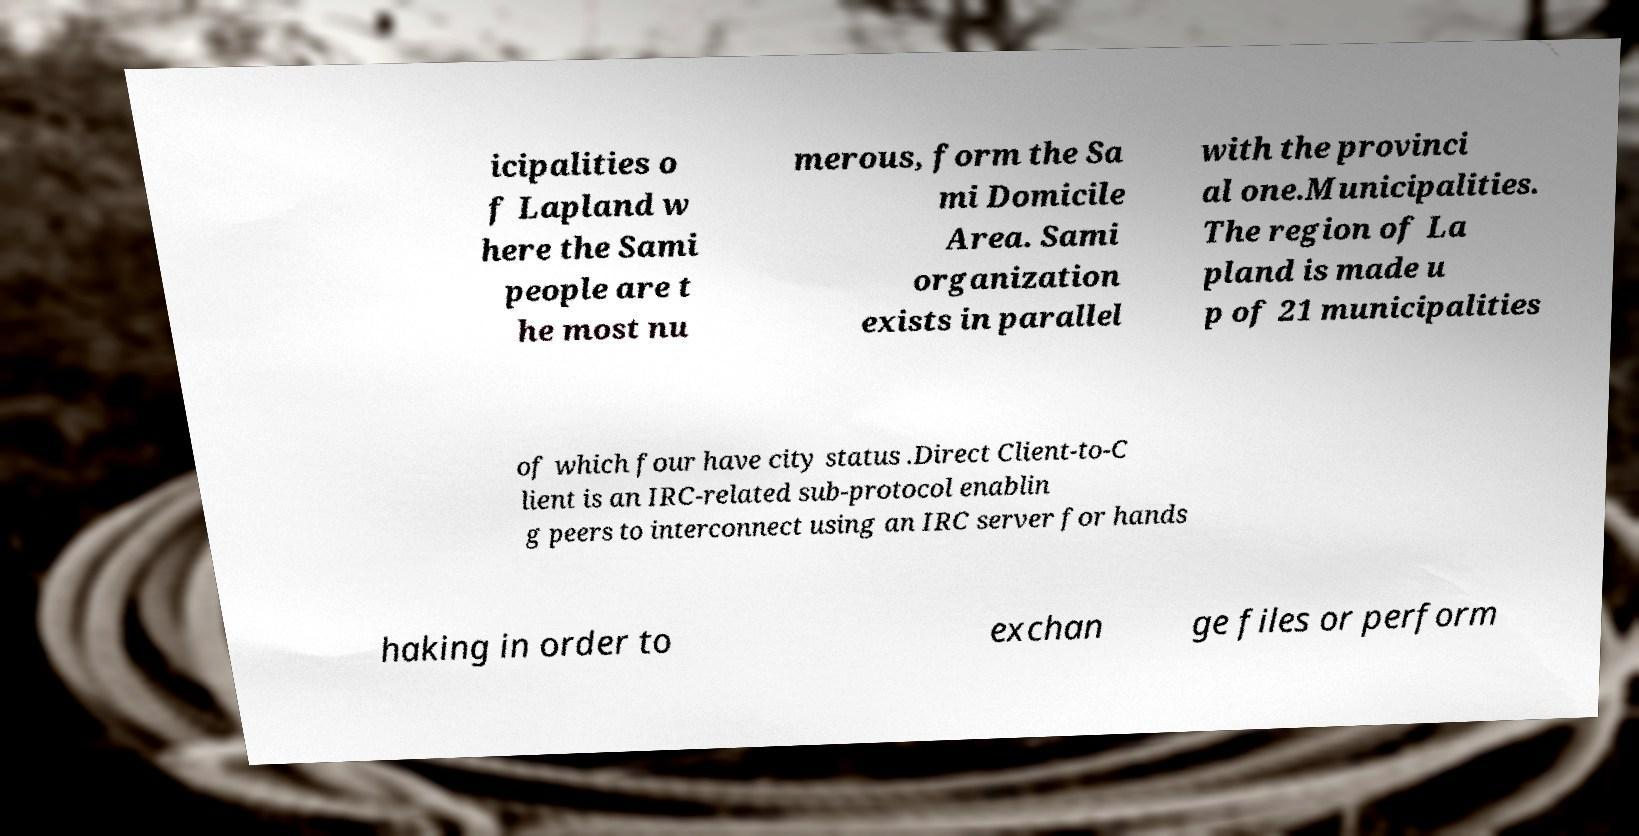What messages or text are displayed in this image? I need them in a readable, typed format. icipalities o f Lapland w here the Sami people are t he most nu merous, form the Sa mi Domicile Area. Sami organization exists in parallel with the provinci al one.Municipalities. The region of La pland is made u p of 21 municipalities of which four have city status .Direct Client-to-C lient is an IRC-related sub-protocol enablin g peers to interconnect using an IRC server for hands haking in order to exchan ge files or perform 